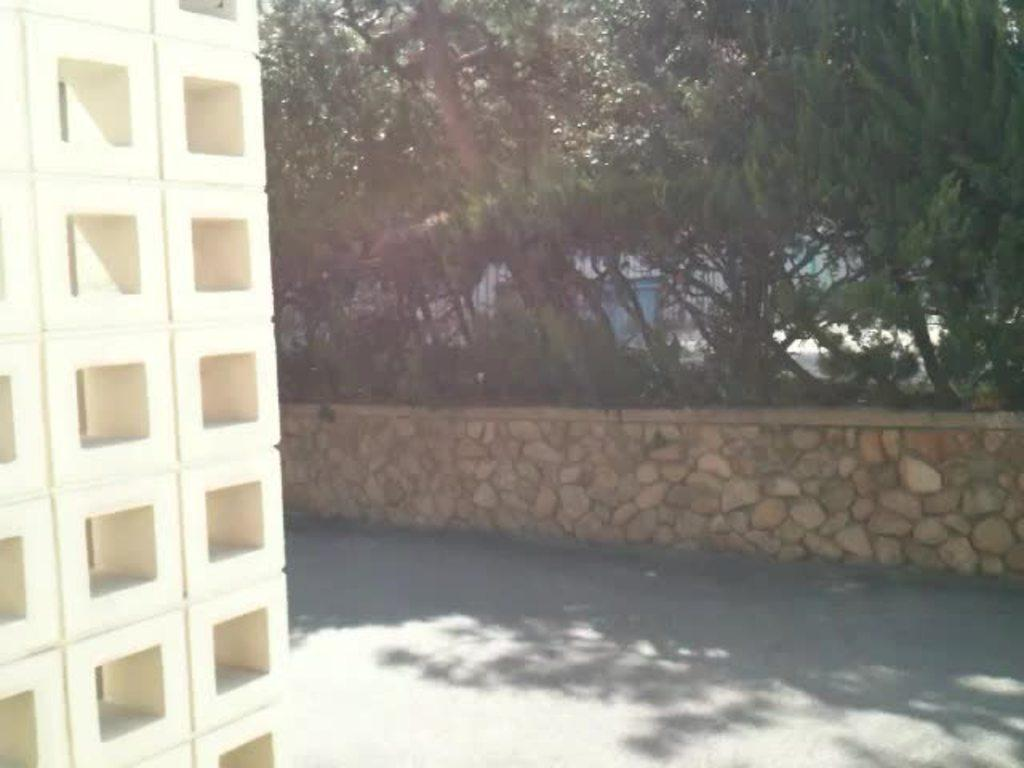What type of vegetation can be seen in the image? There are trees in the image. What is the color of the trees? The trees are green in color. What can be seen in the background of the image? There is an object in the background of the image. What is the color of the object in the background? The object in the background is blue in color. What type of rice is being cooked in the image? There is no rice present in the image; it features trees and an object in the background. Can you see a goat in the image? There is no goat present in the image. 